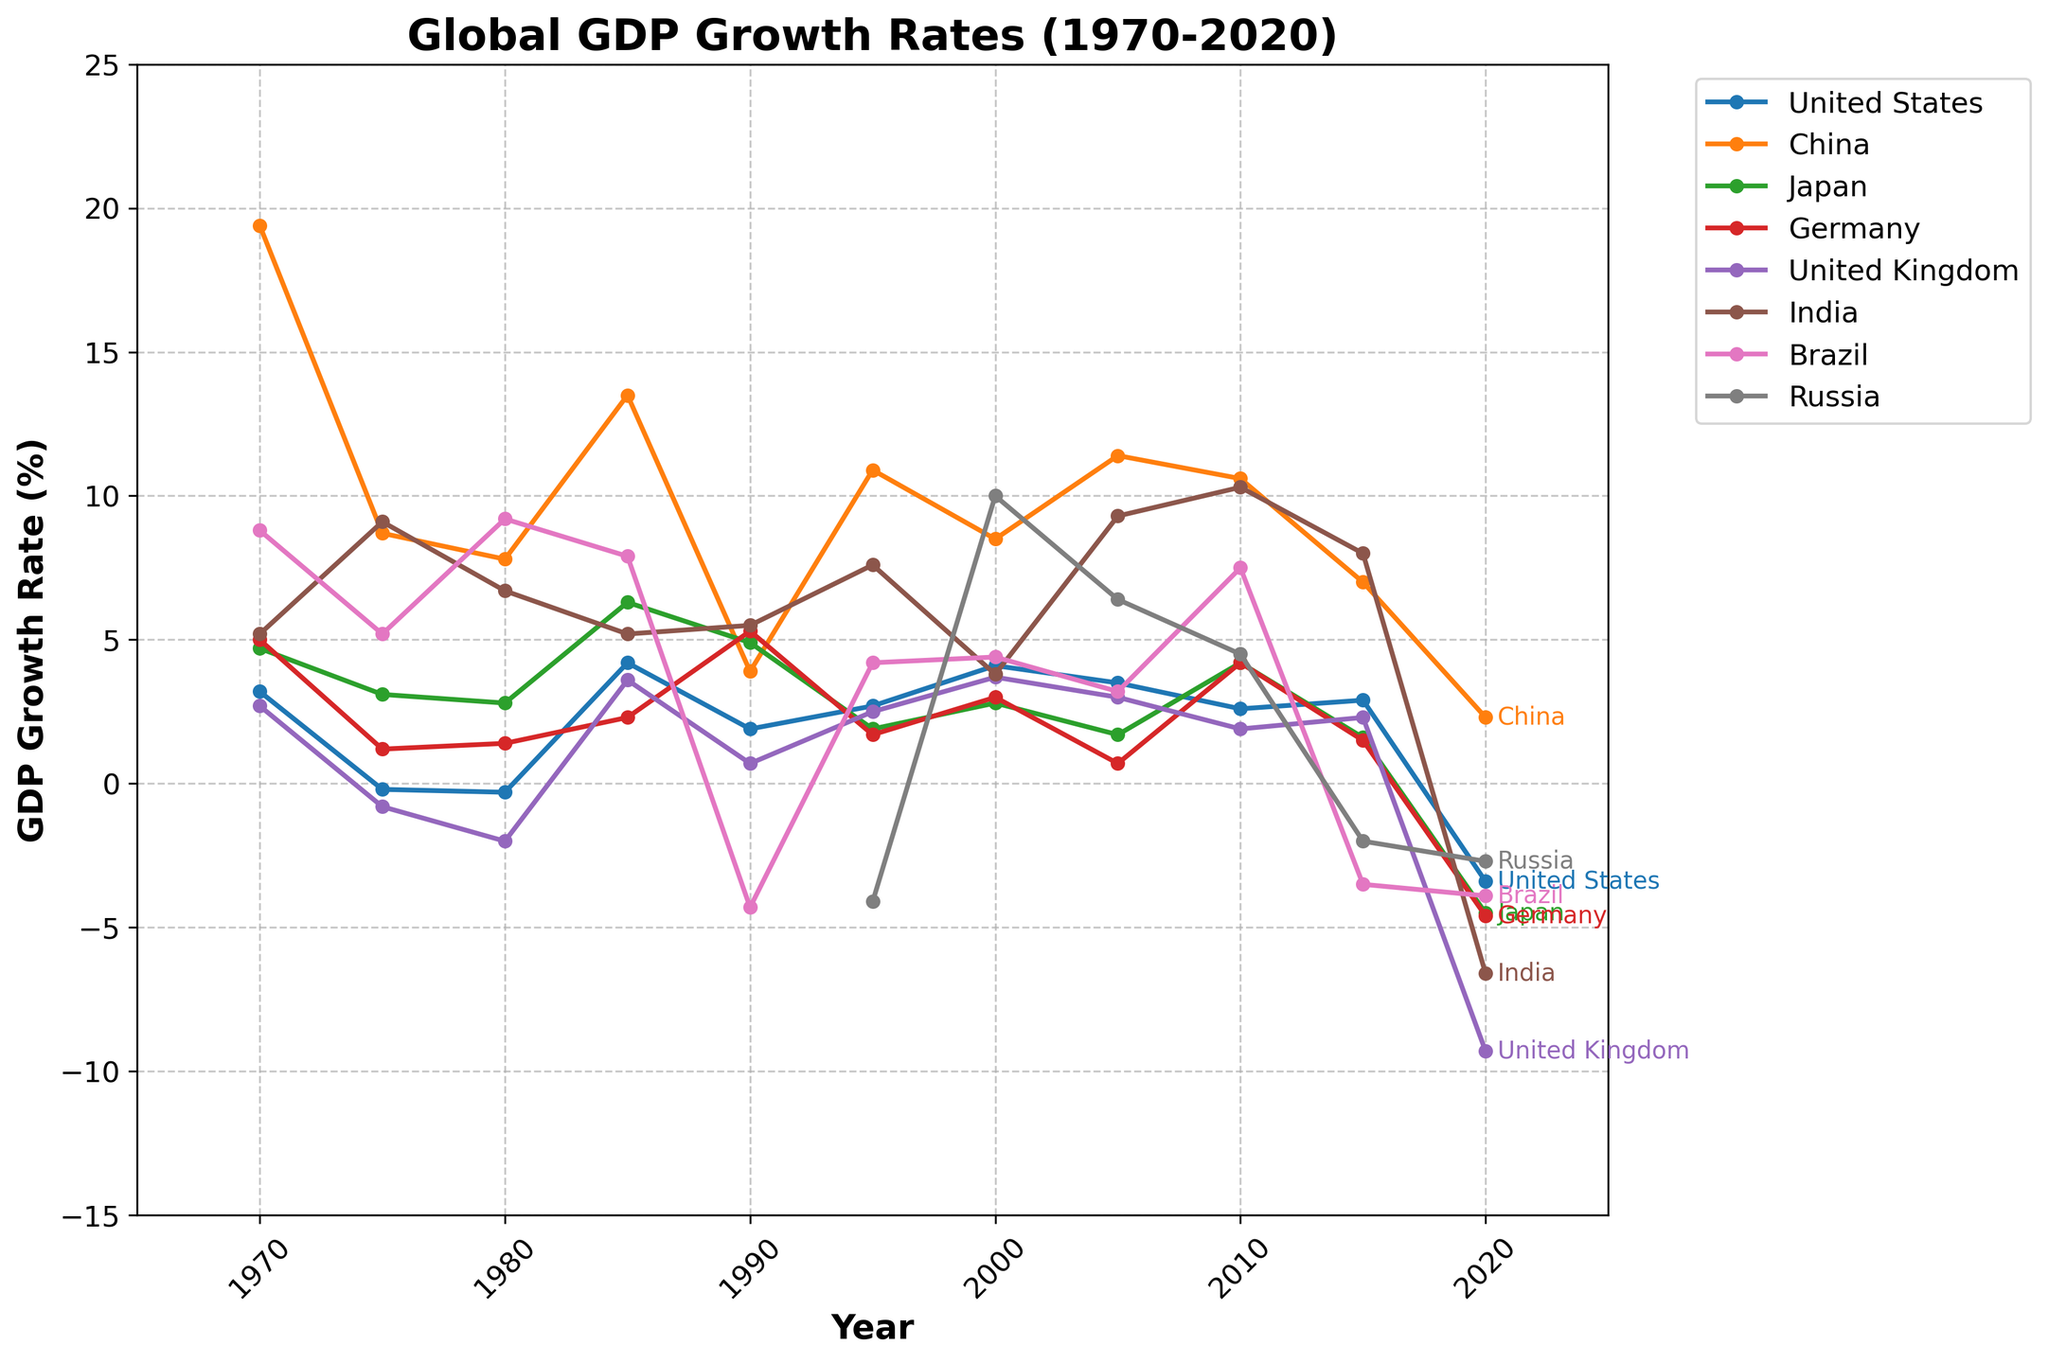Which country had the highest GDP growth rate in 1985? To find this, look at the point that is the highest on the plot line for 1985. From the points on the graph, China has the highest GDP growth rate in 1985 at 13.5%.
Answer: China What was the average GDP growth rate for the United States between 2000 and 2010? Identify the growth rates for the United States in 2000 (4.1%), 2005 (3.5%), and 2010 (2.6%). Sum these values and divide by the number of years. (4.1 + 3.5 + 2.6)/3 = 10.2/3 = 3.4%.
Answer: 3.4% In which year did Germany have the lowest GDP growth rate, and what was the rate? To determine this, look at the line representing Germany and find the lowest point. The lowest GDP growth rate for Germany occurred in 2020 at -4.6%.
Answer: 2020, -4.6% Compare the GDP growth rates of China and India in 2010, which country had a higher rate and by how much? The plot shows China's GDP growth rate in 2010 as 10.6% and India's as 10.3%. Subtract India's rate from China's rate: 10.6% - 10.3% = 0.3%.
Answer: China, by 0.3% What were the GDP growth rates of Brazil in 1970 and 2020, and what was the difference? Locate Brazil's GDP growth rates on the plot for 1970 (8.8%) and 2020 (-3.9%). Calculate the difference: 8.8% - (-3.9%) = 8.8% + 3.9% = 12.7%.
Answer: 12.7% Which countries had negative GDP growth rates in 2020? Identify countries that have points below the 0% line for the year 2020. The countries are United States (-3.4%), Japan (-4.5%), Germany (-4.6%), United Kingdom (-9.3%), India (-6.6%), Brazil (-3.9%), and Russia (-2.7%).
Answer: United States, Japan, Germany, United Kingdom, India, Brazil, Russia Between Germany and Japan, which country had more volatile GDP growth rates from 1970 to 2020? Volatility can be assessed by considering the fluctuations in the plot lines. Japan shows wide fluctuations from positive highs to negative lows more frequently than Germany, especially the sharp decrements around 2020.
Answer: Japan Compare the trends of GDP growth rates for China and Russia from 1970 to 2020. What differences do you observe? By comparing the two lines, China shows a generally upward and higher-trending growth rate, especially peaking around 1985 and maintaining higher percentages. Russia shows more instability, with sharp declines around 1990 and 2015, followed by slower recoveries.
Answer: China has a more consistent and higher growth rate; Russia is more unstable with sharp declines How did the GDP growth rate of the United Kingdom change from 2015 to 2020? Observe the plot line for the United Kingdom between 2015 and 2020. The GDP growth rate decreased from 2.3% in 2015 to -9.3% in 2020.
Answer: Decreased by 11.6% What is the median GDP growth rate for Japan over the years provided? The GDP growth rates for Japan are: 4.7%, 3.1%, 2.8%, 6.3%, 4.9%, 1.9%, 2.8%, 1.7%, 4.2%, 1.6%, -4.5%. Ordering these: -4.5%, 1.6%, 1.7%, 1.9%, 2.8%, 2.8%, 3.1%, 4.2%, 4.7%, 4.9%, 6.3%. The median is the middle value: 2.8%.
Answer: 2.8% 